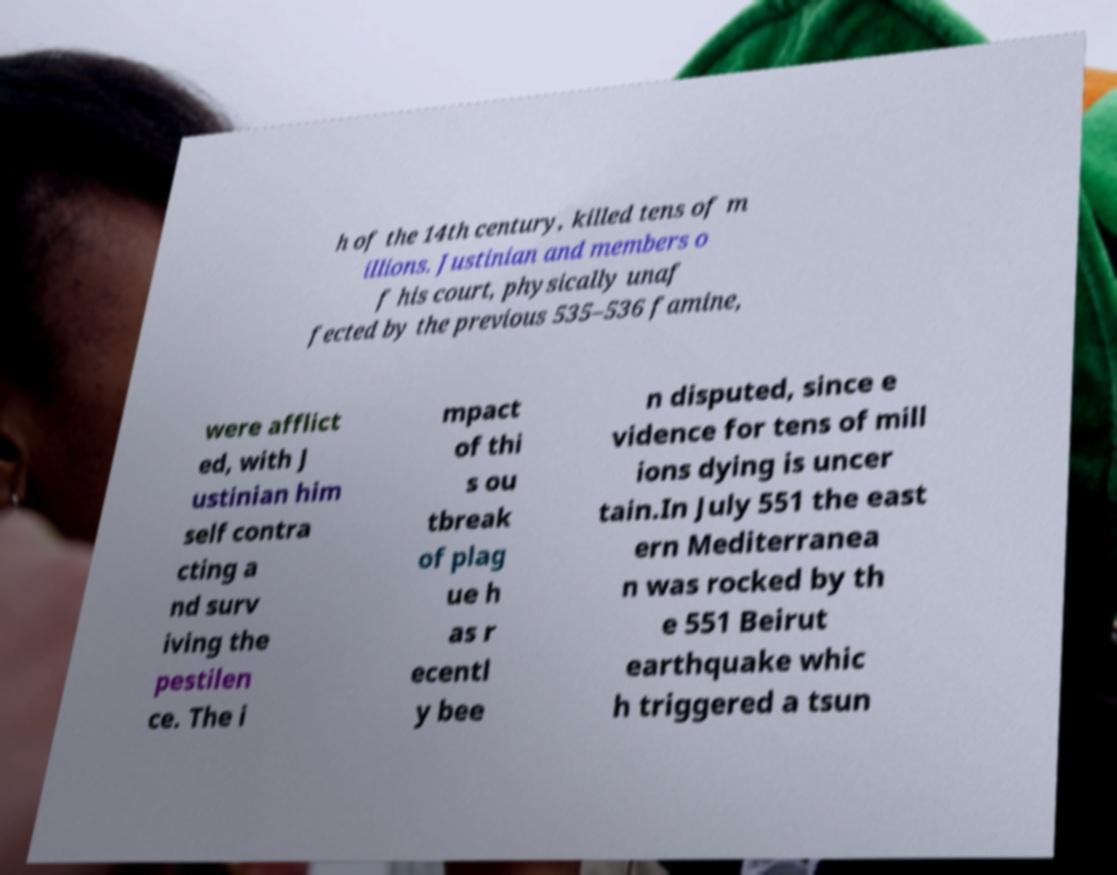Please read and relay the text visible in this image. What does it say? h of the 14th century, killed tens of m illions. Justinian and members o f his court, physically unaf fected by the previous 535–536 famine, were afflict ed, with J ustinian him self contra cting a nd surv iving the pestilen ce. The i mpact of thi s ou tbreak of plag ue h as r ecentl y bee n disputed, since e vidence for tens of mill ions dying is uncer tain.In July 551 the east ern Mediterranea n was rocked by th e 551 Beirut earthquake whic h triggered a tsun 